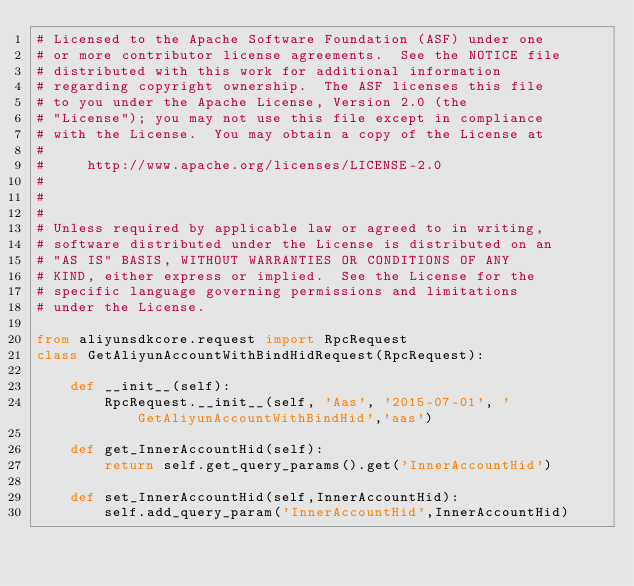Convert code to text. <code><loc_0><loc_0><loc_500><loc_500><_Python_># Licensed to the Apache Software Foundation (ASF) under one
# or more contributor license agreements.  See the NOTICE file
# distributed with this work for additional information
# regarding copyright ownership.  The ASF licenses this file
# to you under the Apache License, Version 2.0 (the
# "License"); you may not use this file except in compliance
# with the License.  You may obtain a copy of the License at
#
#     http://www.apache.org/licenses/LICENSE-2.0
#
#
#
# Unless required by applicable law or agreed to in writing,
# software distributed under the License is distributed on an
# "AS IS" BASIS, WITHOUT WARRANTIES OR CONDITIONS OF ANY
# KIND, either express or implied.  See the License for the
# specific language governing permissions and limitations
# under the License.

from aliyunsdkcore.request import RpcRequest
class GetAliyunAccountWithBindHidRequest(RpcRequest):

	def __init__(self):
		RpcRequest.__init__(self, 'Aas', '2015-07-01', 'GetAliyunAccountWithBindHid','aas')

	def get_InnerAccountHid(self):
		return self.get_query_params().get('InnerAccountHid')

	def set_InnerAccountHid(self,InnerAccountHid):
		self.add_query_param('InnerAccountHid',InnerAccountHid)</code> 